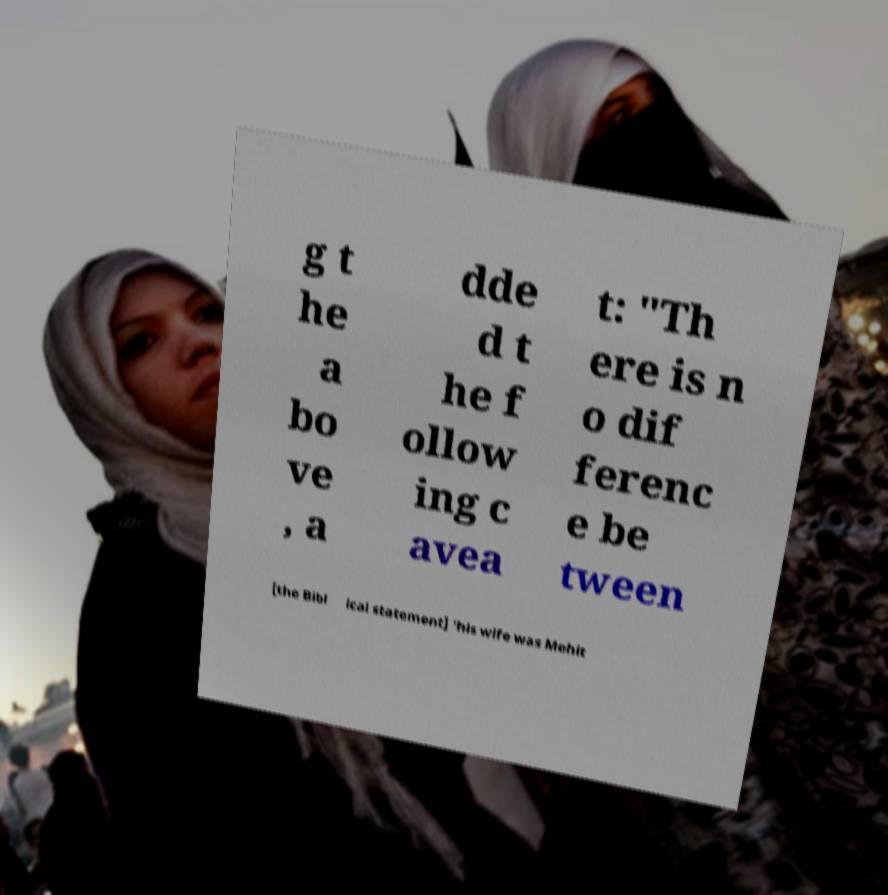Please read and relay the text visible in this image. What does it say? g t he a bo ve , a dde d t he f ollow ing c avea t: "Th ere is n o dif ferenc e be tween [the Bibl ical statement] 'his wife was Mehit 